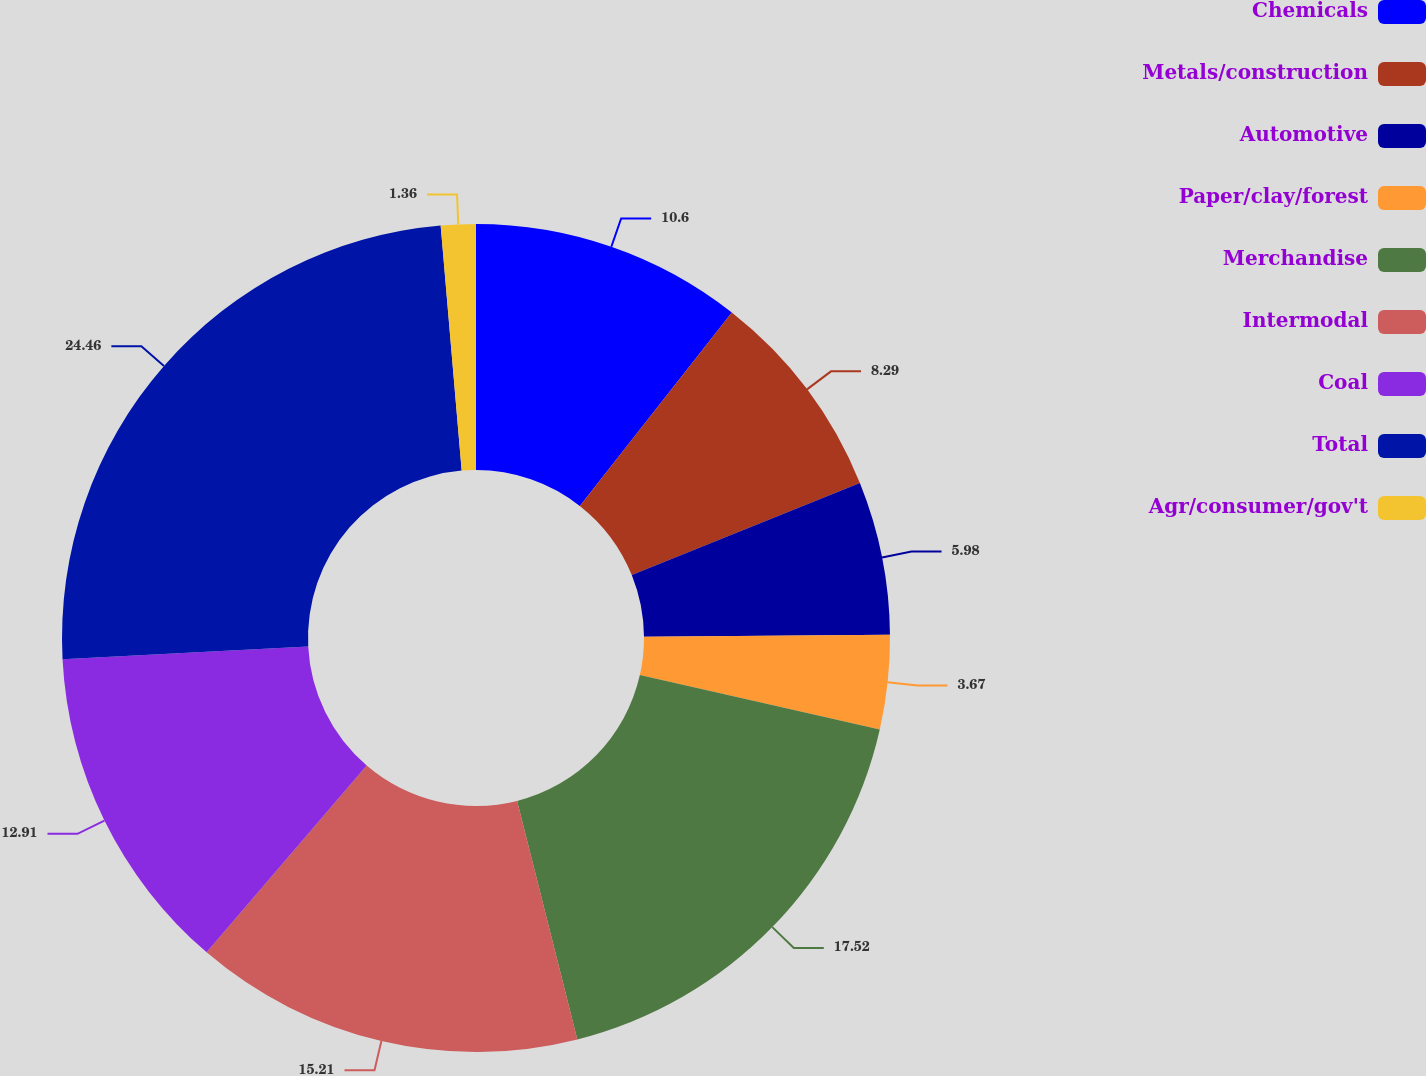Convert chart. <chart><loc_0><loc_0><loc_500><loc_500><pie_chart><fcel>Chemicals<fcel>Metals/construction<fcel>Automotive<fcel>Paper/clay/forest<fcel>Merchandise<fcel>Intermodal<fcel>Coal<fcel>Total<fcel>Agr/consumer/gov't<nl><fcel>10.6%<fcel>8.29%<fcel>5.98%<fcel>3.67%<fcel>17.52%<fcel>15.21%<fcel>12.91%<fcel>24.45%<fcel>1.36%<nl></chart> 